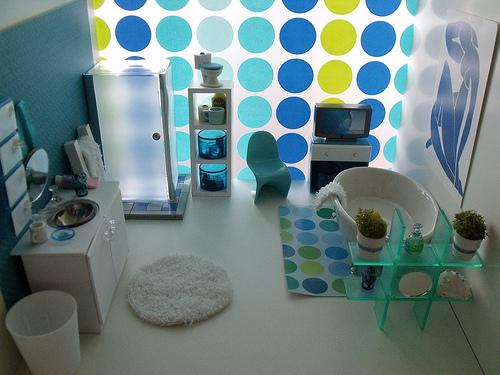Question: who is sitting in the chair?
Choices:
A. No one.
B. An old lady.
C. A young man.
D. A dog.
Answer with the letter. Answer: A Question: how many potted plants are there?
Choices:
A. One.
B. Three.
C. Four.
D. Two.
Answer with the letter. Answer: D Question: what shape is the mirror?
Choices:
A. Circle.
B. Oval.
C. Rectangle.
D. Square.
Answer with the letter. Answer: A Question: what design is on the wall?
Choices:
A. Stripes.
B. Plaid.
C. Diamonds.
D. Polka dots.
Answer with the letter. Answer: D Question: what is hanging on the wall?
Choices:
A. A coat rack.
B. Art.
C. Sconce.
D. A picture.
Answer with the letter. Answer: D 